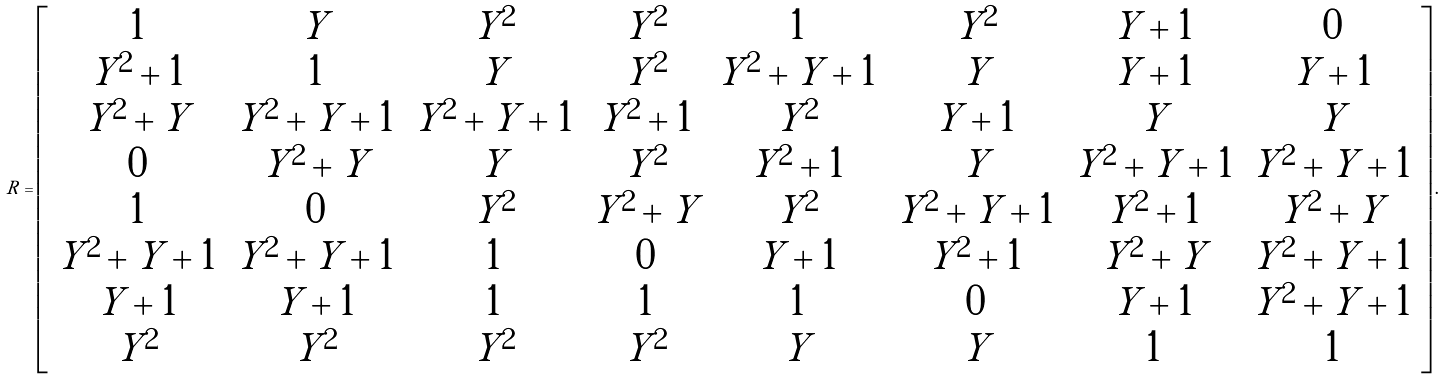Convert formula to latex. <formula><loc_0><loc_0><loc_500><loc_500>R = \left [ \begin{array} { c c c c c c c c } 1 & Y & Y ^ { 2 } & Y ^ { 2 } & 1 & Y ^ { 2 } & Y + 1 & 0 \\ Y ^ { 2 } + 1 & 1 & Y & Y ^ { 2 } & Y ^ { 2 } + Y + 1 & Y & Y + 1 & Y + 1 \\ Y ^ { 2 } + Y & Y ^ { 2 } + Y + 1 & Y ^ { 2 } + Y + 1 & Y ^ { 2 } + 1 & Y ^ { 2 } & Y + 1 & Y & Y \\ 0 & Y ^ { 2 } + Y & Y & Y ^ { 2 } & Y ^ { 2 } + 1 & Y & Y ^ { 2 } + Y + 1 & Y ^ { 2 } + Y + 1 \\ 1 & 0 & Y ^ { 2 } & Y ^ { 2 } + Y & Y ^ { 2 } & Y ^ { 2 } + Y + 1 & Y ^ { 2 } + 1 & Y ^ { 2 } + Y \\ Y ^ { 2 } + Y + 1 & Y ^ { 2 } + Y + 1 & 1 & 0 & Y + 1 & Y ^ { 2 } + 1 & Y ^ { 2 } + Y & Y ^ { 2 } + Y + 1 \\ Y + 1 & Y + 1 & 1 & 1 & 1 & 0 & Y + 1 & Y ^ { 2 } + Y + 1 \\ Y ^ { 2 } & Y ^ { 2 } & Y ^ { 2 } & Y ^ { 2 } & Y & Y & 1 & 1 \end{array} \right ] .</formula> 